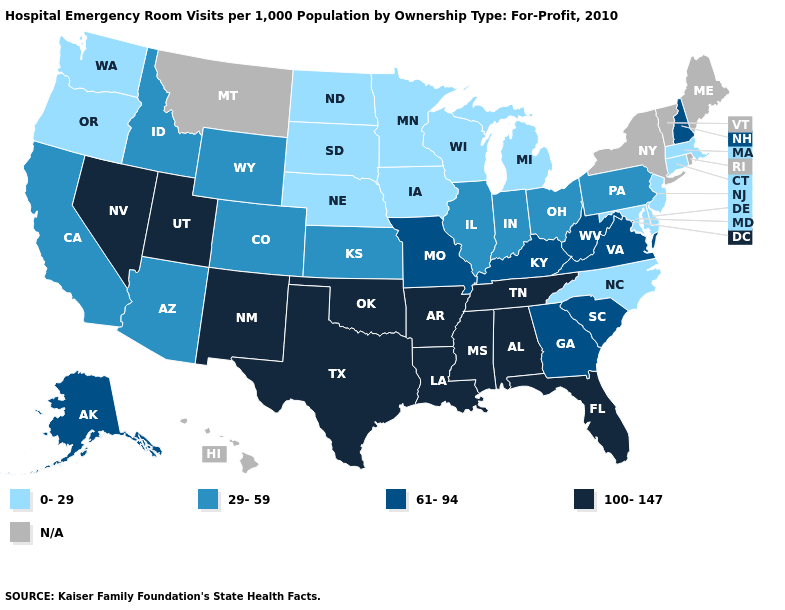What is the highest value in the MidWest ?
Be succinct. 61-94. Is the legend a continuous bar?
Answer briefly. No. Name the states that have a value in the range N/A?
Quick response, please. Hawaii, Maine, Montana, New York, Rhode Island, Vermont. What is the lowest value in the USA?
Be succinct. 0-29. Name the states that have a value in the range 61-94?
Short answer required. Alaska, Georgia, Kentucky, Missouri, New Hampshire, South Carolina, Virginia, West Virginia. Name the states that have a value in the range 61-94?
Keep it brief. Alaska, Georgia, Kentucky, Missouri, New Hampshire, South Carolina, Virginia, West Virginia. Name the states that have a value in the range 61-94?
Be succinct. Alaska, Georgia, Kentucky, Missouri, New Hampshire, South Carolina, Virginia, West Virginia. Name the states that have a value in the range 61-94?
Short answer required. Alaska, Georgia, Kentucky, Missouri, New Hampshire, South Carolina, Virginia, West Virginia. Name the states that have a value in the range 0-29?
Write a very short answer. Connecticut, Delaware, Iowa, Maryland, Massachusetts, Michigan, Minnesota, Nebraska, New Jersey, North Carolina, North Dakota, Oregon, South Dakota, Washington, Wisconsin. What is the highest value in the USA?
Write a very short answer. 100-147. Name the states that have a value in the range 29-59?
Concise answer only. Arizona, California, Colorado, Idaho, Illinois, Indiana, Kansas, Ohio, Pennsylvania, Wyoming. How many symbols are there in the legend?
Be succinct. 5. Which states hav the highest value in the Northeast?
Short answer required. New Hampshire. Name the states that have a value in the range 0-29?
Quick response, please. Connecticut, Delaware, Iowa, Maryland, Massachusetts, Michigan, Minnesota, Nebraska, New Jersey, North Carolina, North Dakota, Oregon, South Dakota, Washington, Wisconsin. 